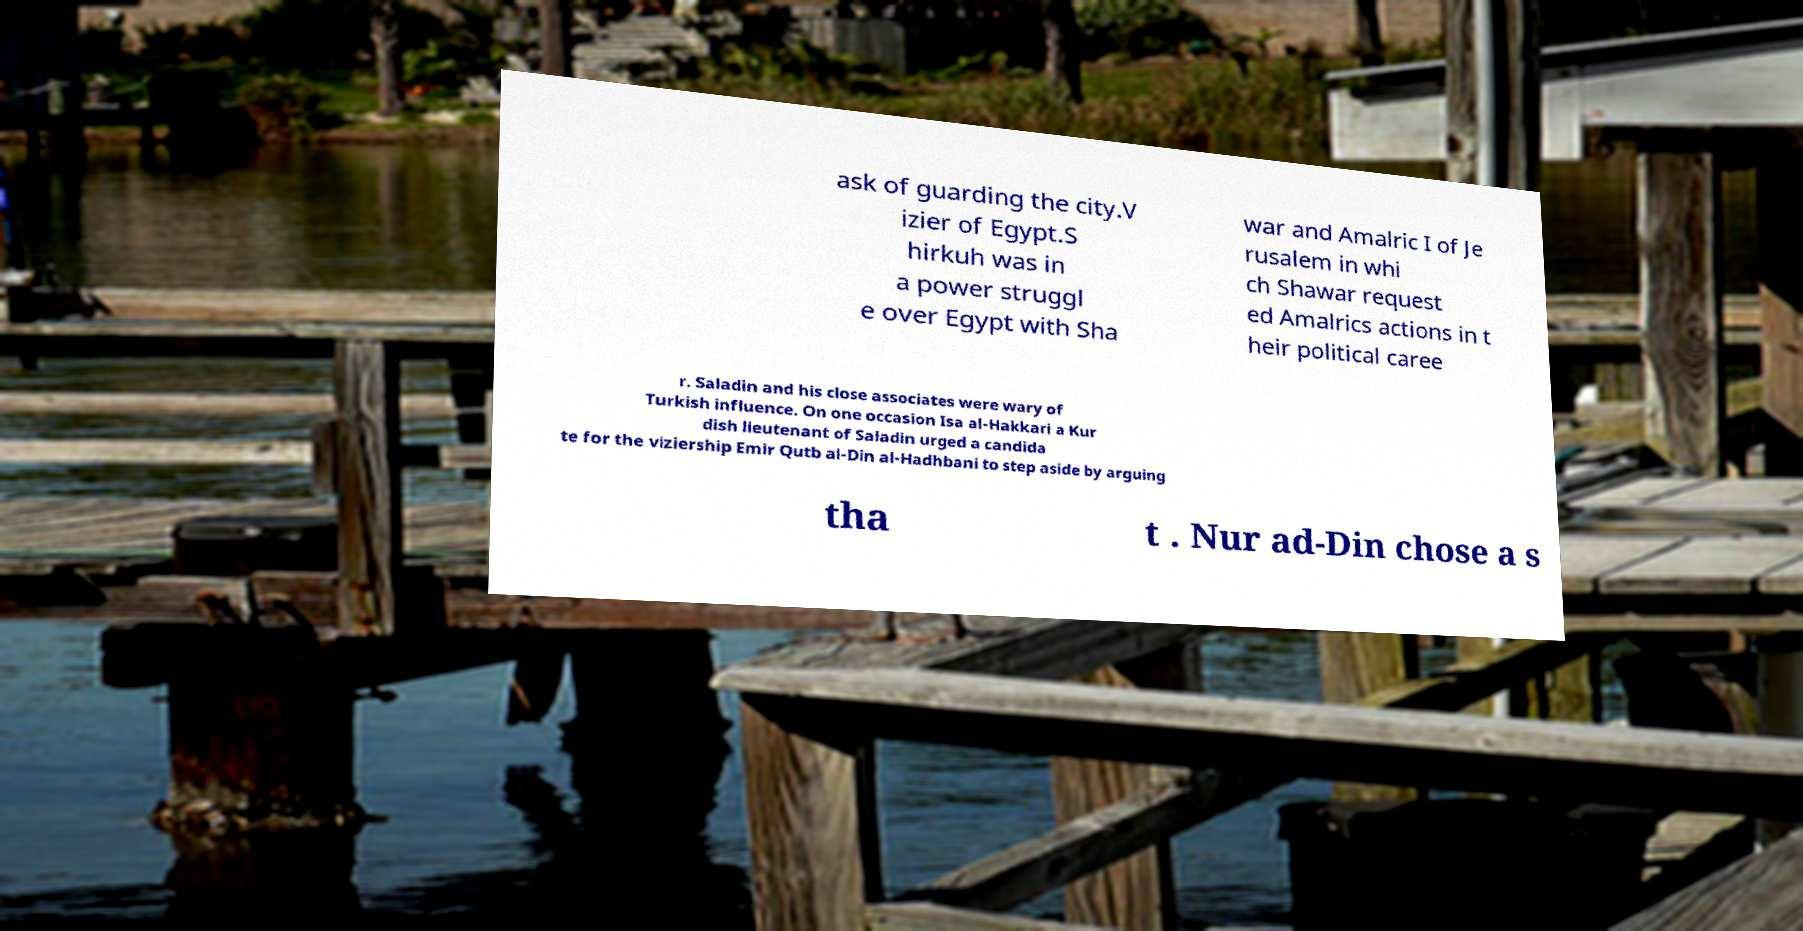Can you accurately transcribe the text from the provided image for me? ask of guarding the city.V izier of Egypt.S hirkuh was in a power struggl e over Egypt with Sha war and Amalric I of Je rusalem in whi ch Shawar request ed Amalrics actions in t heir political caree r. Saladin and his close associates were wary of Turkish influence. On one occasion Isa al-Hakkari a Kur dish lieutenant of Saladin urged a candida te for the viziership Emir Qutb al-Din al-Hadhbani to step aside by arguing tha t . Nur ad-Din chose a s 